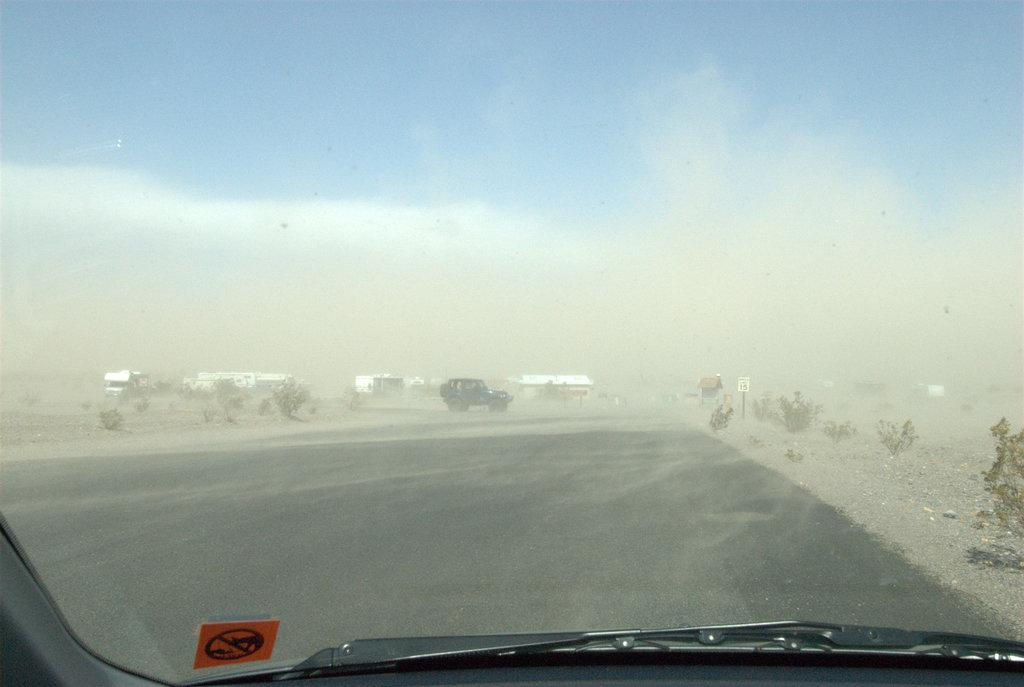What can be seen in the sky in the image? The sky with clouds is visible in the image. What type of transportation can be seen in the image? Motor vehicles are present in the image. What type of vegetation is visible in the image? Bushes are visible in the image. What surface can be seen in the image? A road is visible in the image. From where is the view of the image taken? The view is through a vehicle's window. Is there an island visible through the vehicle's window in the image? There is no island visible through the vehicle's window in the image. What shape is the square that is present in the image? There is no square present in the image. 